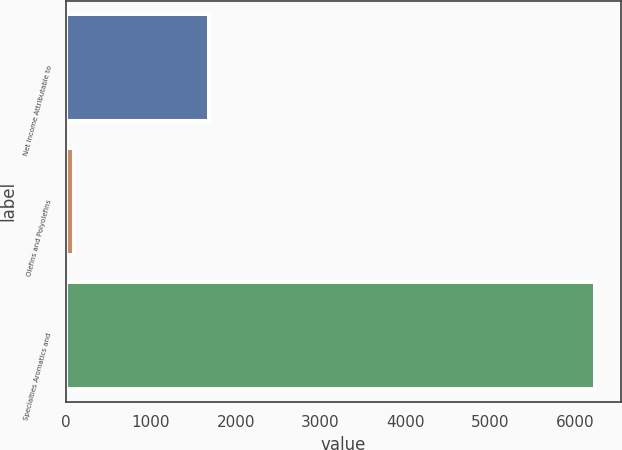<chart> <loc_0><loc_0><loc_500><loc_500><bar_chart><fcel>Net Income Attributable to<fcel>Olefins and Polyolefins<fcel>Specialties Aromatics and<nl><fcel>1686.3<fcel>88<fcel>6230<nl></chart> 